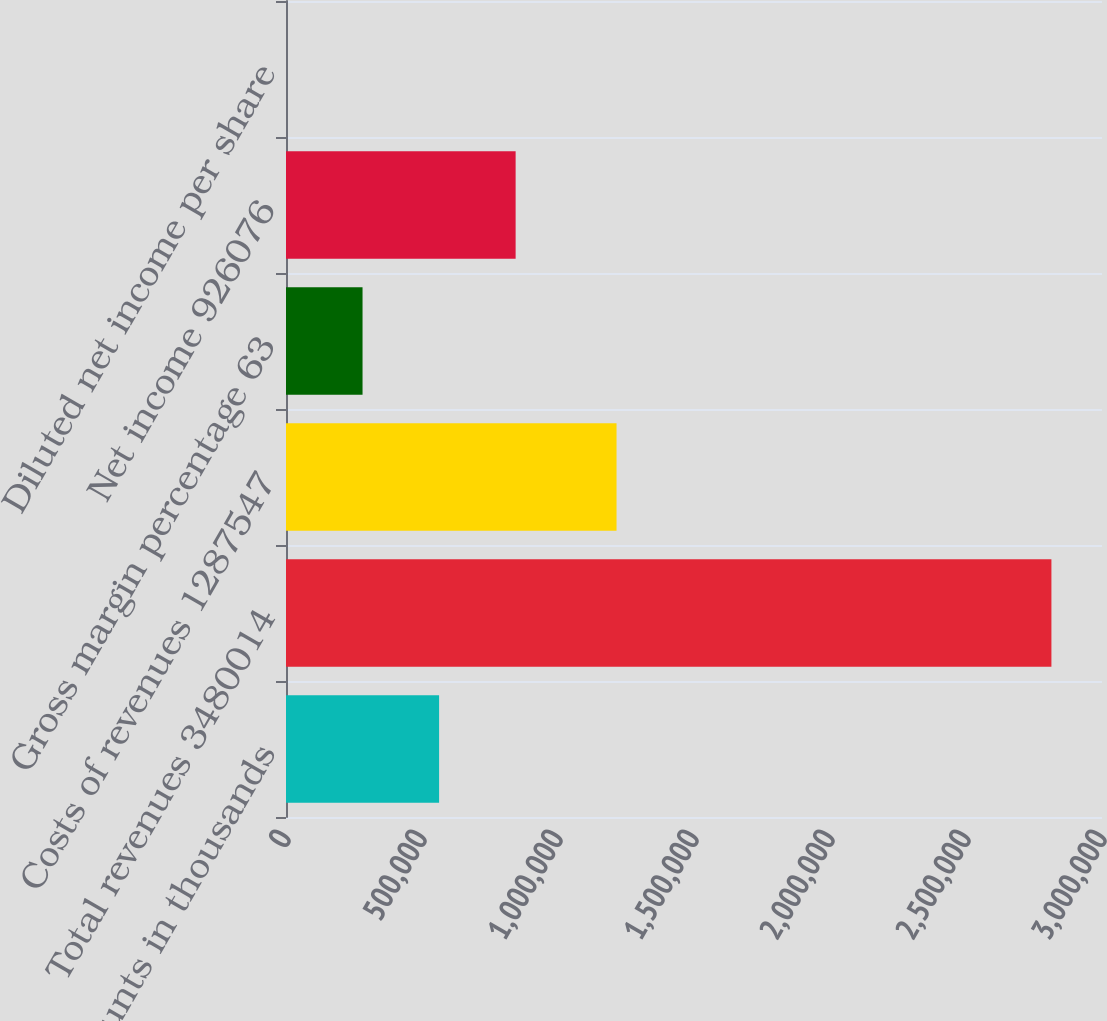Convert chart to OTSL. <chart><loc_0><loc_0><loc_500><loc_500><bar_chart><fcel>(Dollar amounts in thousands<fcel>Total revenues 3480014<fcel>Costs of revenues 1287547<fcel>Gross margin percentage 63<fcel>Net income 926076<fcel>Diluted net income per share<nl><fcel>562812<fcel>2.81405e+06<fcel>1.21523e+06<fcel>281407<fcel>844216<fcel>2.24<nl></chart> 